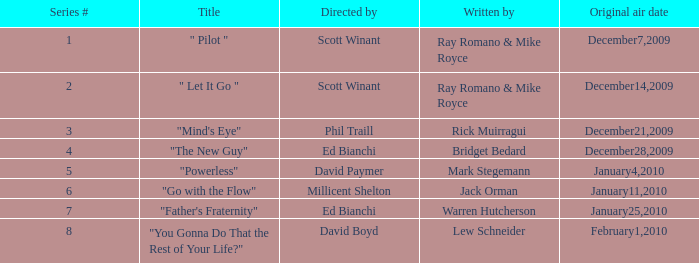How many episodes are written by Lew Schneider? 1.0. 